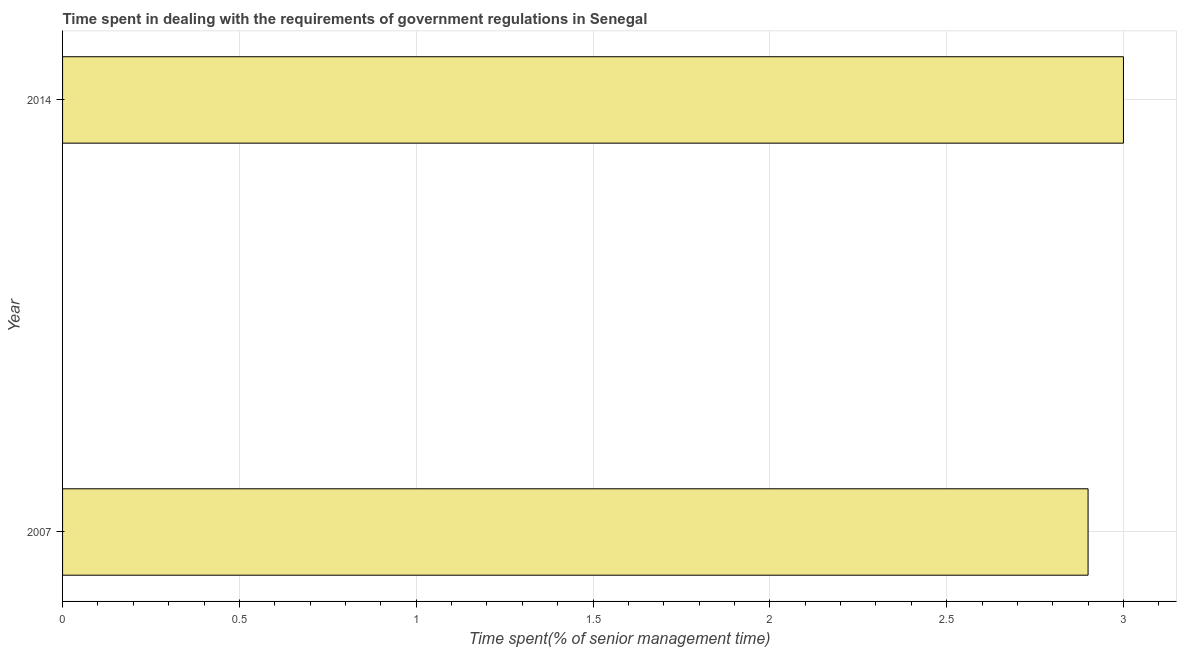What is the title of the graph?
Offer a terse response. Time spent in dealing with the requirements of government regulations in Senegal. What is the label or title of the X-axis?
Offer a terse response. Time spent(% of senior management time). What is the label or title of the Y-axis?
Provide a succinct answer. Year. What is the time spent in dealing with government regulations in 2014?
Your response must be concise. 3. Across all years, what is the minimum time spent in dealing with government regulations?
Keep it short and to the point. 2.9. What is the difference between the time spent in dealing with government regulations in 2007 and 2014?
Give a very brief answer. -0.1. What is the average time spent in dealing with government regulations per year?
Your answer should be very brief. 2.95. What is the median time spent in dealing with government regulations?
Your answer should be very brief. 2.95. In how many years, is the time spent in dealing with government regulations greater than 2.9 %?
Ensure brevity in your answer.  1. What is the ratio of the time spent in dealing with government regulations in 2007 to that in 2014?
Give a very brief answer. 0.97. Is the time spent in dealing with government regulations in 2007 less than that in 2014?
Give a very brief answer. Yes. How many bars are there?
Offer a very short reply. 2. Are all the bars in the graph horizontal?
Provide a short and direct response. Yes. How many years are there in the graph?
Provide a short and direct response. 2. What is the difference between the Time spent(% of senior management time) in 2007 and 2014?
Keep it short and to the point. -0.1. 